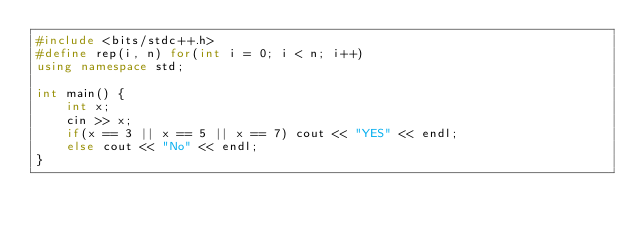<code> <loc_0><loc_0><loc_500><loc_500><_C++_>#include <bits/stdc++.h>
#define rep(i, n) for(int i = 0; i < n; i++)
using namespace std;

int main() {
    int x;
    cin >> x;
    if(x == 3 || x == 5 || x == 7) cout << "YES" << endl;
    else cout << "No" << endl;
}</code> 